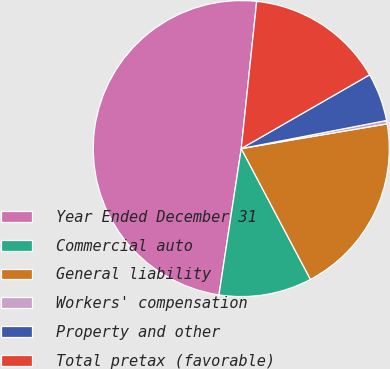Convert chart. <chart><loc_0><loc_0><loc_500><loc_500><pie_chart><fcel>Year Ended December 31<fcel>Commercial auto<fcel>General liability<fcel>Workers' compensation<fcel>Property and other<fcel>Total pretax (favorable)<nl><fcel>49.27%<fcel>10.15%<fcel>19.93%<fcel>0.37%<fcel>5.26%<fcel>15.04%<nl></chart> 